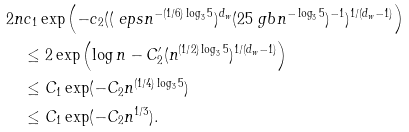<formula> <loc_0><loc_0><loc_500><loc_500>& 2 n c _ { 1 } \exp \left ( - c _ { 2 } ( ( \ e p s n ^ { - ( 1 / 6 ) \log _ { 3 } 5 } ) ^ { d _ { w } } ( 2 5 \ g b n ^ { - \log _ { 3 } 5 } ) ^ { - 1 } ) ^ { 1 / ( d _ { w } - 1 ) } \right ) \\ & \quad \leq 2 \exp \left ( \log n - C ^ { \prime } _ { 2 } ( n ^ { ( 1 / 2 ) \log _ { 3 } 5 } ) ^ { 1 / ( d _ { w } - 1 ) } \right ) \\ & \quad \leq C _ { 1 } \exp ( - C _ { 2 } n ^ { ( 1 / 4 ) \log _ { 3 } 5 } ) \\ & \quad \leq C _ { 1 } \exp ( - C _ { 2 } n ^ { 1 / 3 } ) . \\</formula> 